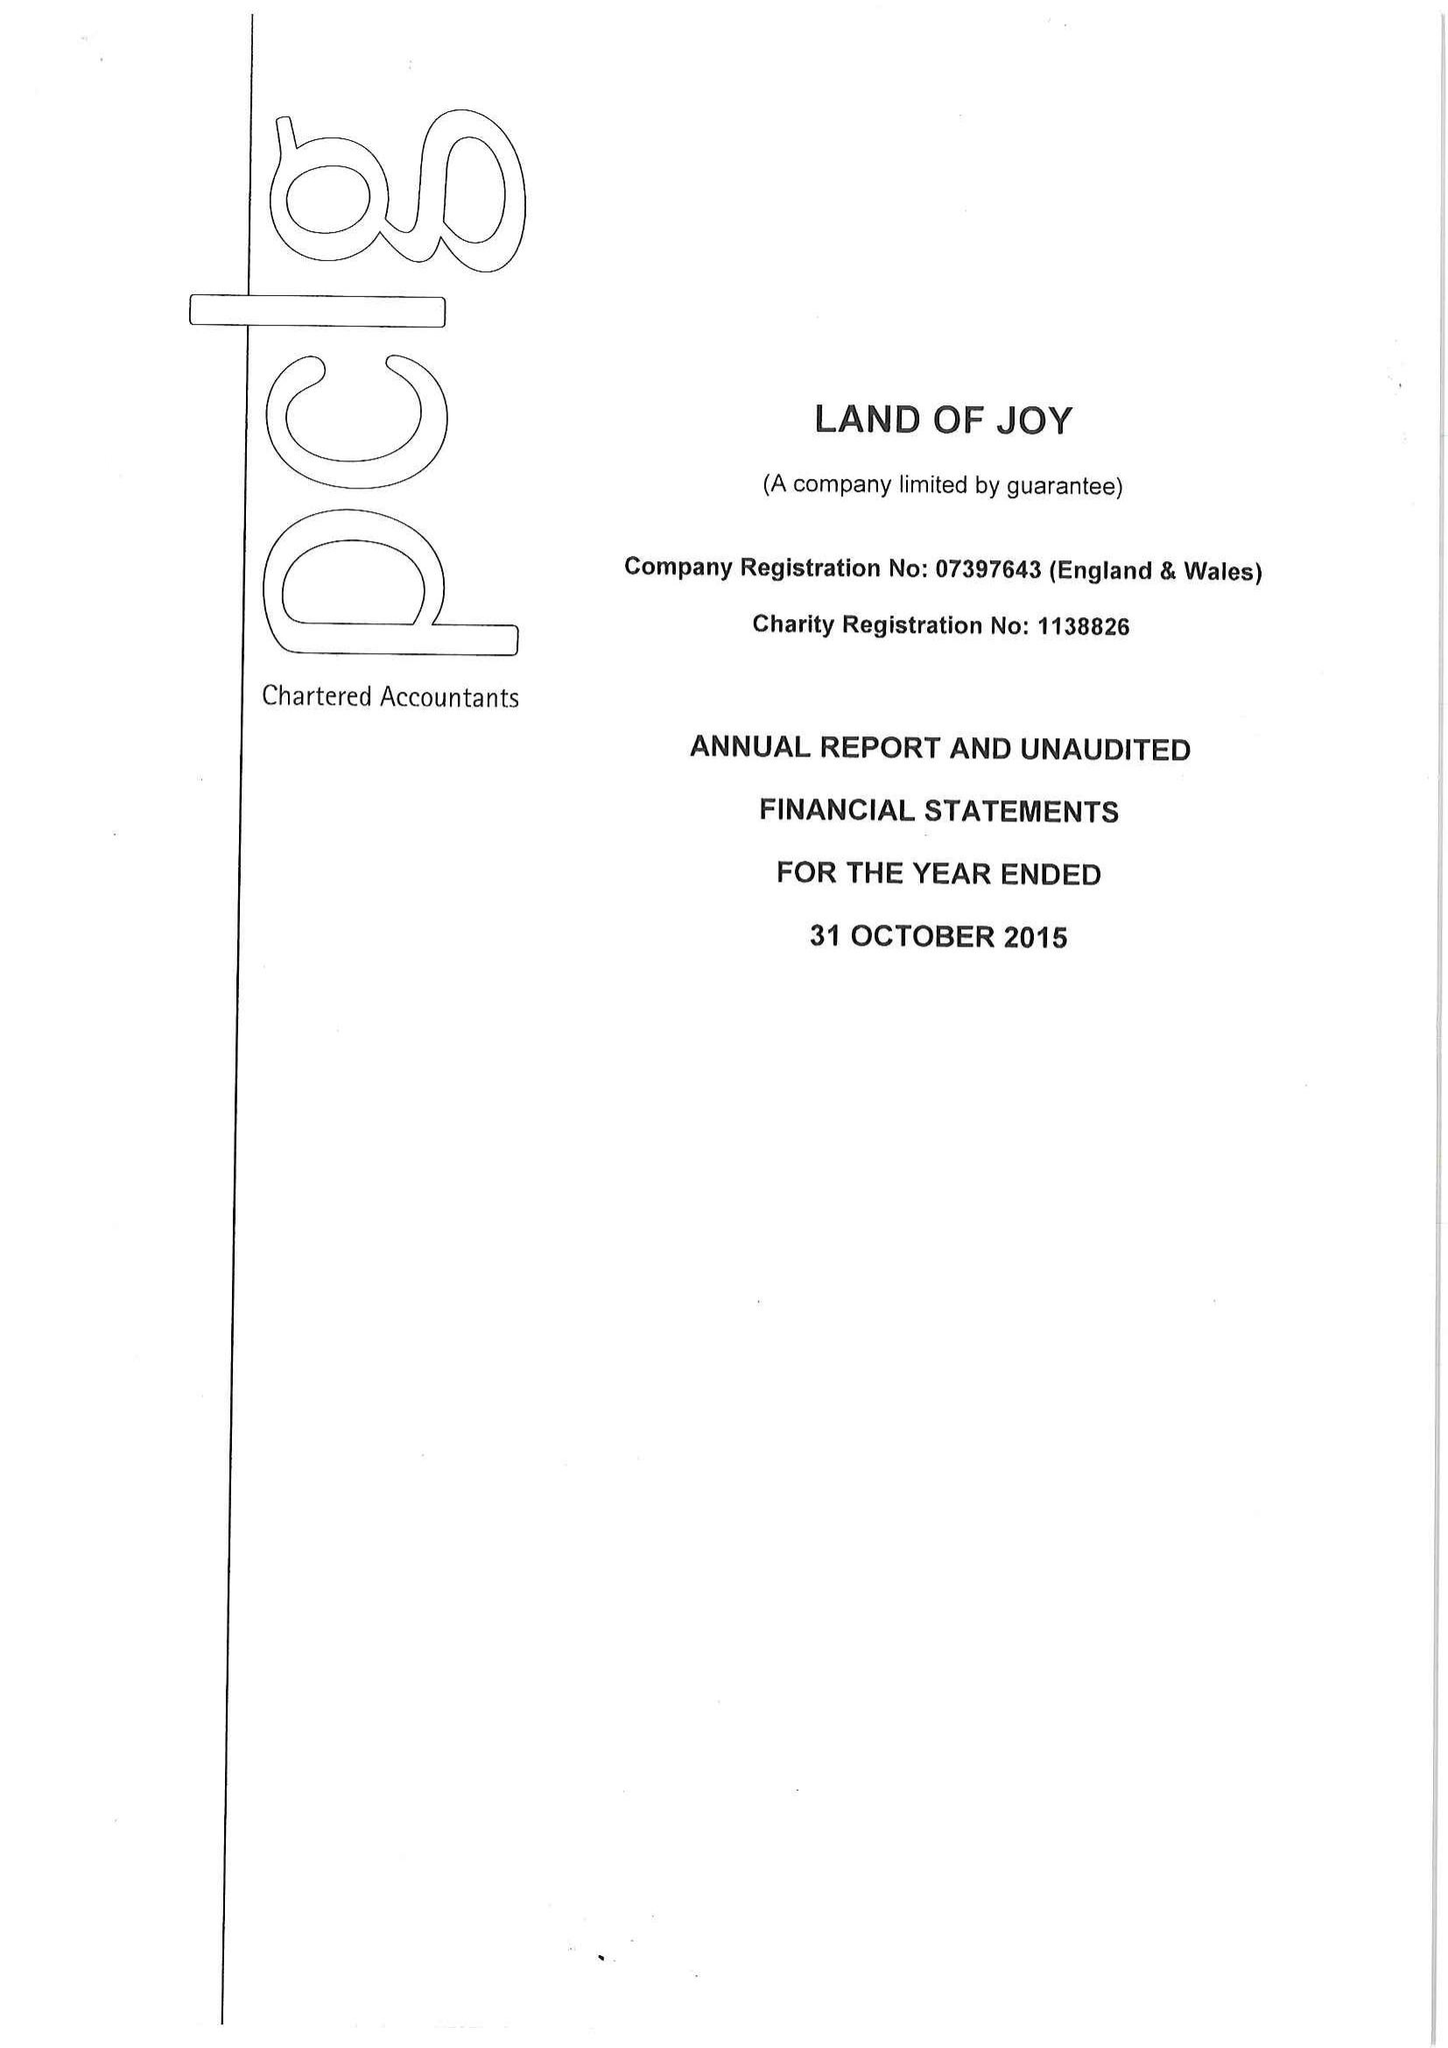What is the value for the spending_annually_in_british_pounds?
Answer the question using a single word or phrase. 65521.00 